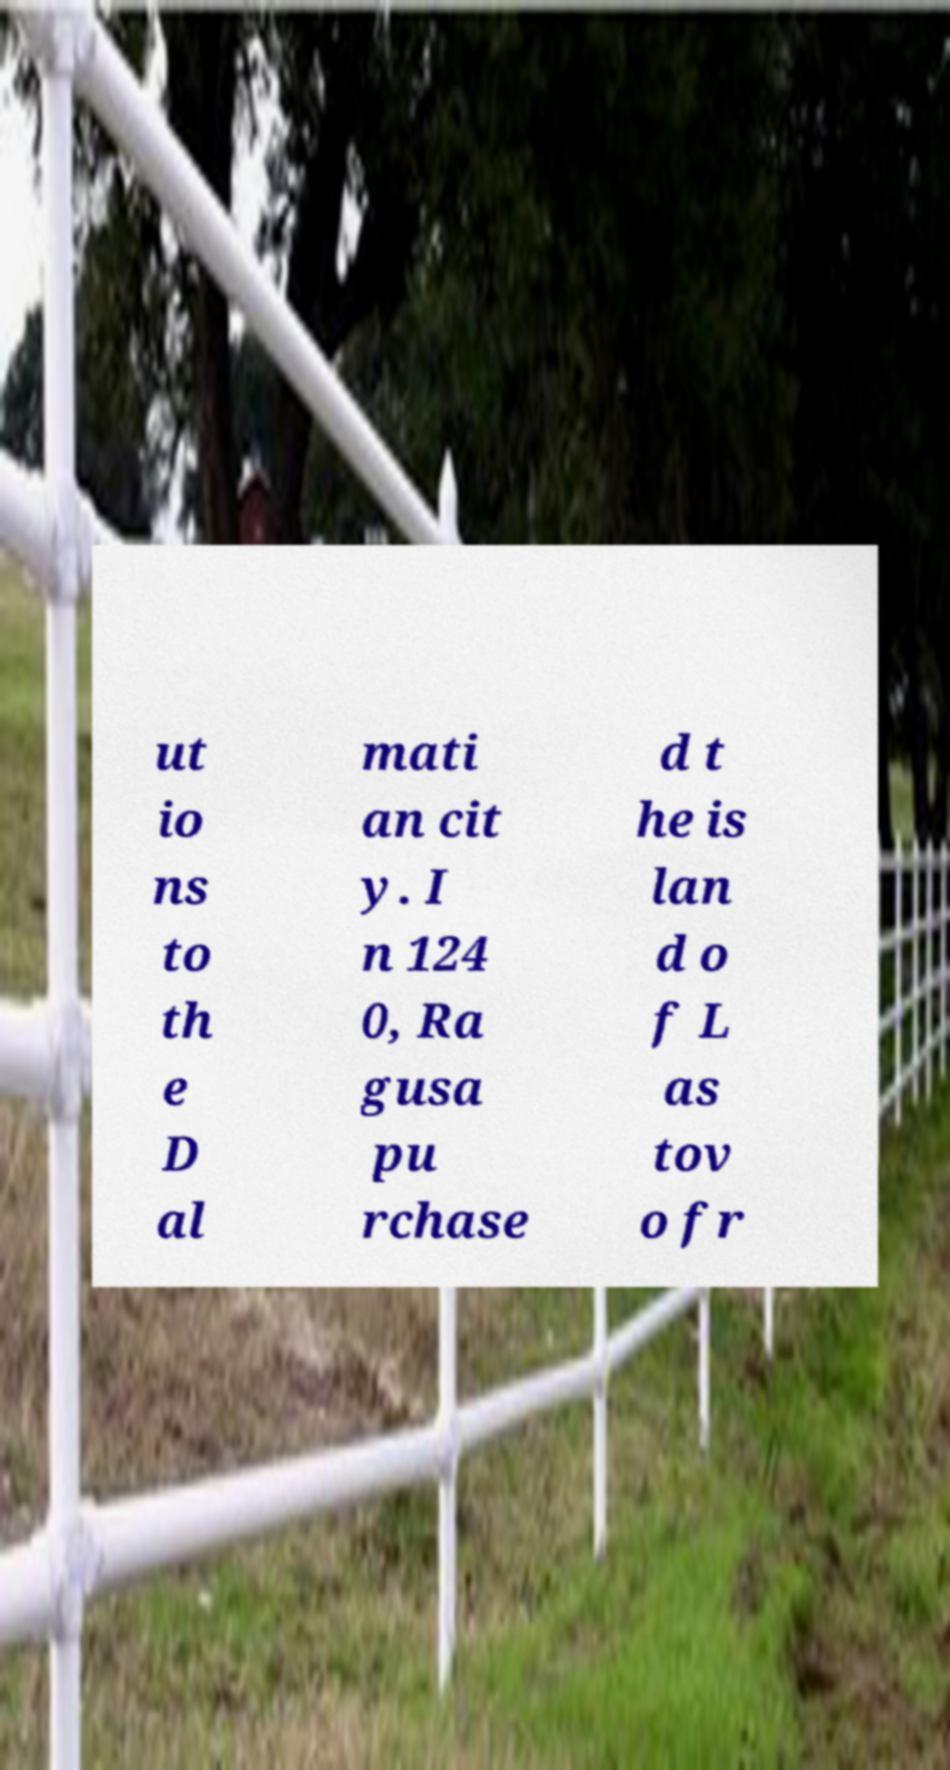There's text embedded in this image that I need extracted. Can you transcribe it verbatim? ut io ns to th e D al mati an cit y. I n 124 0, Ra gusa pu rchase d t he is lan d o f L as tov o fr 